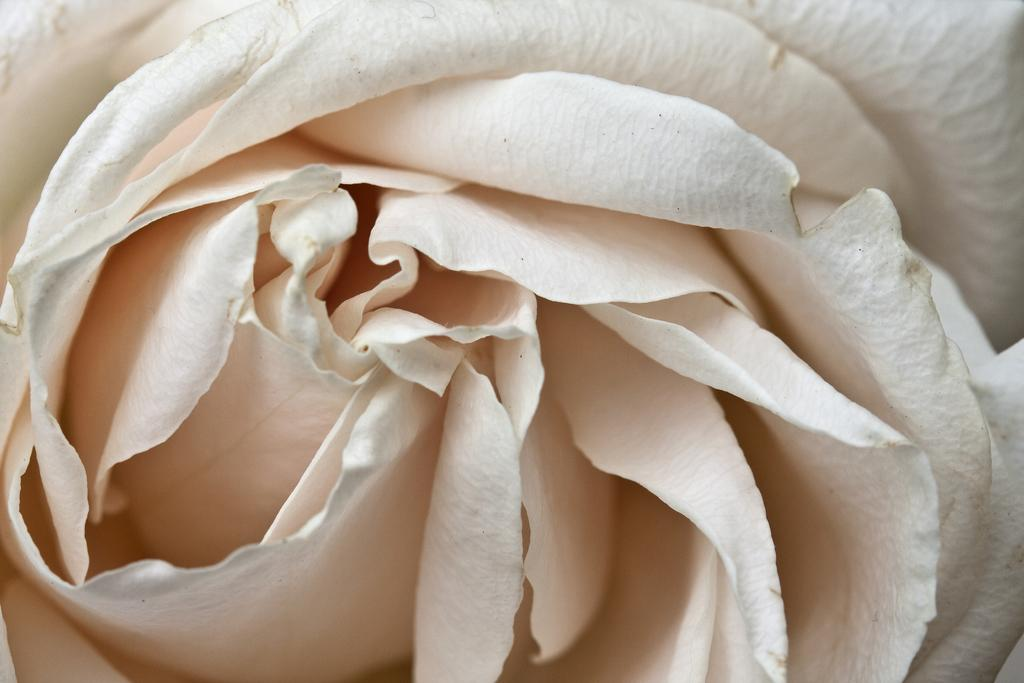What is the main subject of the image? There is a flower in the image. What type of shoe is being discussed in the lunchroom scene depicted in the image? There is no lunchroom scene or shoe present in the image; it features a flower. 